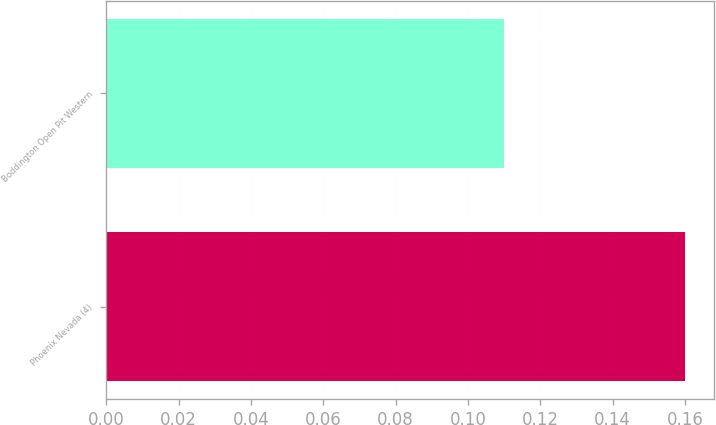<chart> <loc_0><loc_0><loc_500><loc_500><bar_chart><fcel>Phoenix Nevada (4)<fcel>Boddington Open Pit Western<nl><fcel>0.16<fcel>0.11<nl></chart> 